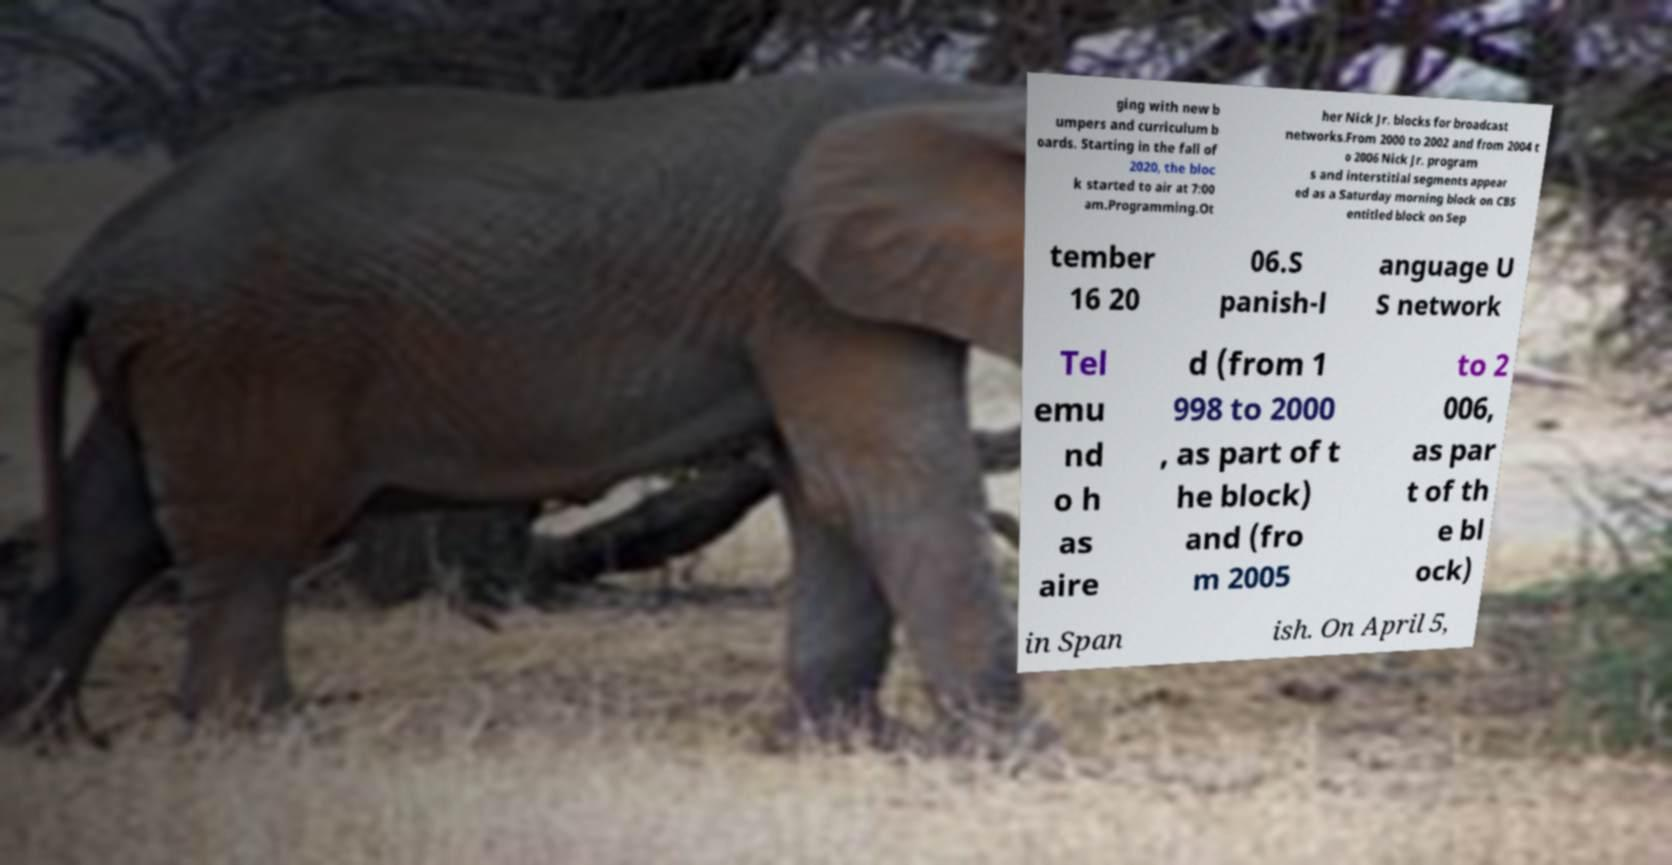Please identify and transcribe the text found in this image. ging with new b umpers and curriculum b oards. Starting in the fall of 2020, the bloc k started to air at 7:00 am.Programming.Ot her Nick Jr. blocks for broadcast networks.From 2000 to 2002 and from 2004 t o 2006 Nick Jr. program s and interstitial segments appear ed as a Saturday morning block on CBS entitled block on Sep tember 16 20 06.S panish-l anguage U S network Tel emu nd o h as aire d (from 1 998 to 2000 , as part of t he block) and (fro m 2005 to 2 006, as par t of th e bl ock) in Span ish. On April 5, 